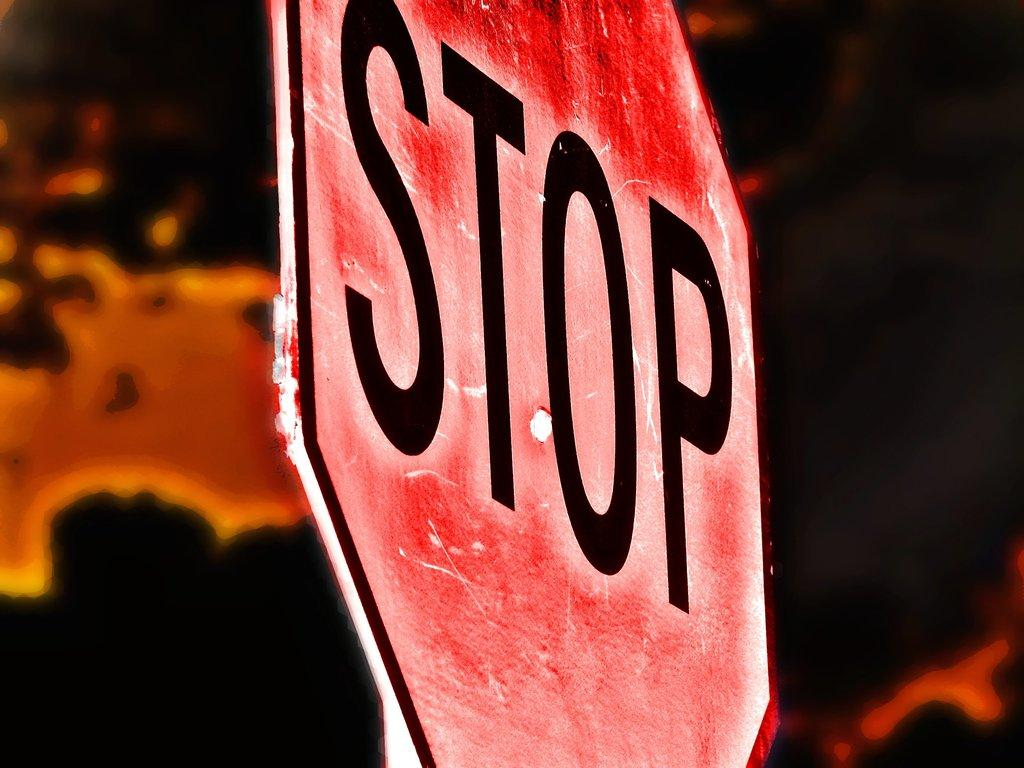Provide a one-sentence caption for the provided image. A red octagon sign with the letters STOP in Black on it. 